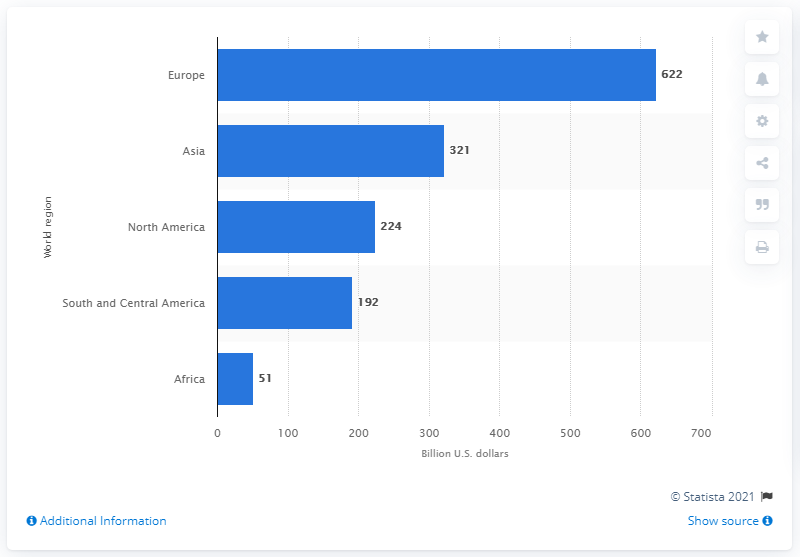Mention a couple of crucial points in this snapshot. According to statistics from 2014, the combined export value of food from South and Central America was 192 billion U.S. dollars. 